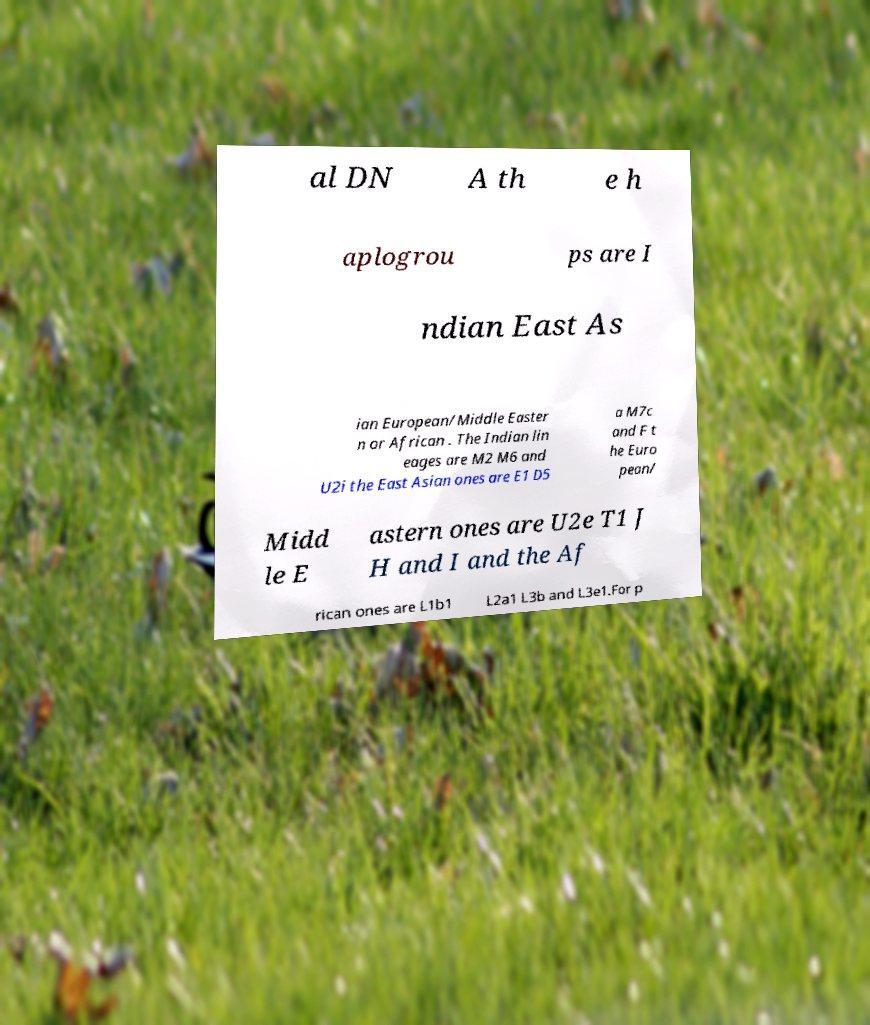Can you accurately transcribe the text from the provided image for me? al DN A th e h aplogrou ps are I ndian East As ian European/Middle Easter n or African . The Indian lin eages are M2 M6 and U2i the East Asian ones are E1 D5 a M7c and F t he Euro pean/ Midd le E astern ones are U2e T1 J H and I and the Af rican ones are L1b1 L2a1 L3b and L3e1.For p 